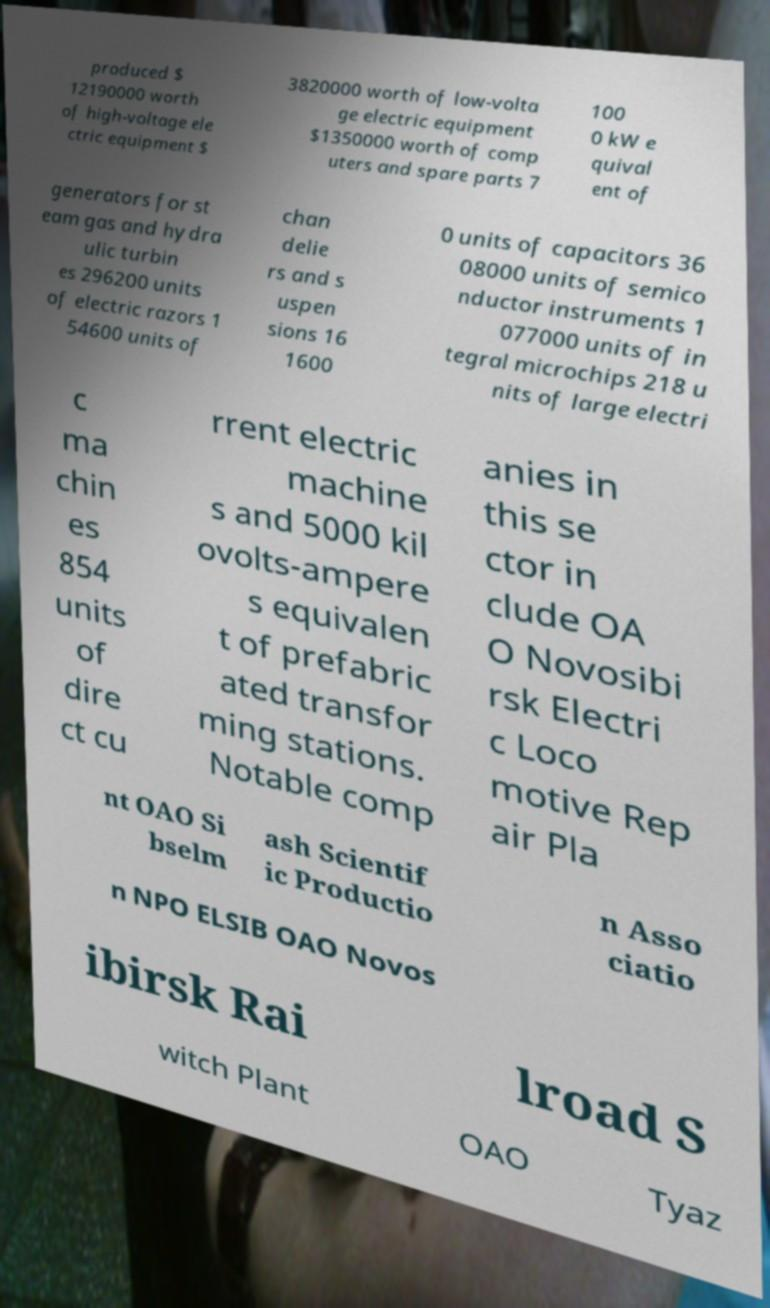Can you read and provide the text displayed in the image?This photo seems to have some interesting text. Can you extract and type it out for me? produced $ 12190000 worth of high-voltage ele ctric equipment $ 3820000 worth of low-volta ge electric equipment $1350000 worth of comp uters and spare parts 7 100 0 kW e quival ent of generators for st eam gas and hydra ulic turbin es 296200 units of electric razors 1 54600 units of chan delie rs and s uspen sions 16 1600 0 units of capacitors 36 08000 units of semico nductor instruments 1 077000 units of in tegral microchips 218 u nits of large electri c ma chin es 854 units of dire ct cu rrent electric machine s and 5000 kil ovolts-ampere s equivalen t of prefabric ated transfor ming stations. Notable comp anies in this se ctor in clude OA O Novosibi rsk Electri c Loco motive Rep air Pla nt OAO Si bselm ash Scientif ic Productio n Asso ciatio n NPO ELSIB OAO Novos ibirsk Rai lroad S witch Plant OAO Tyaz 